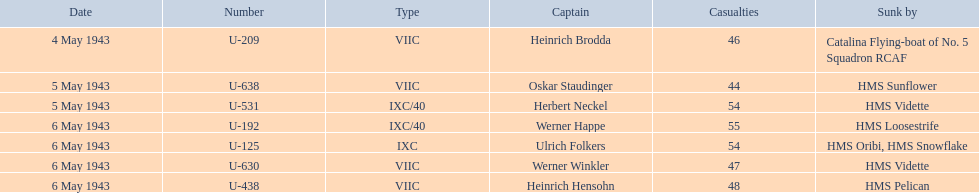How many more casualties occurred on may 6 compared to may 4? 158. 